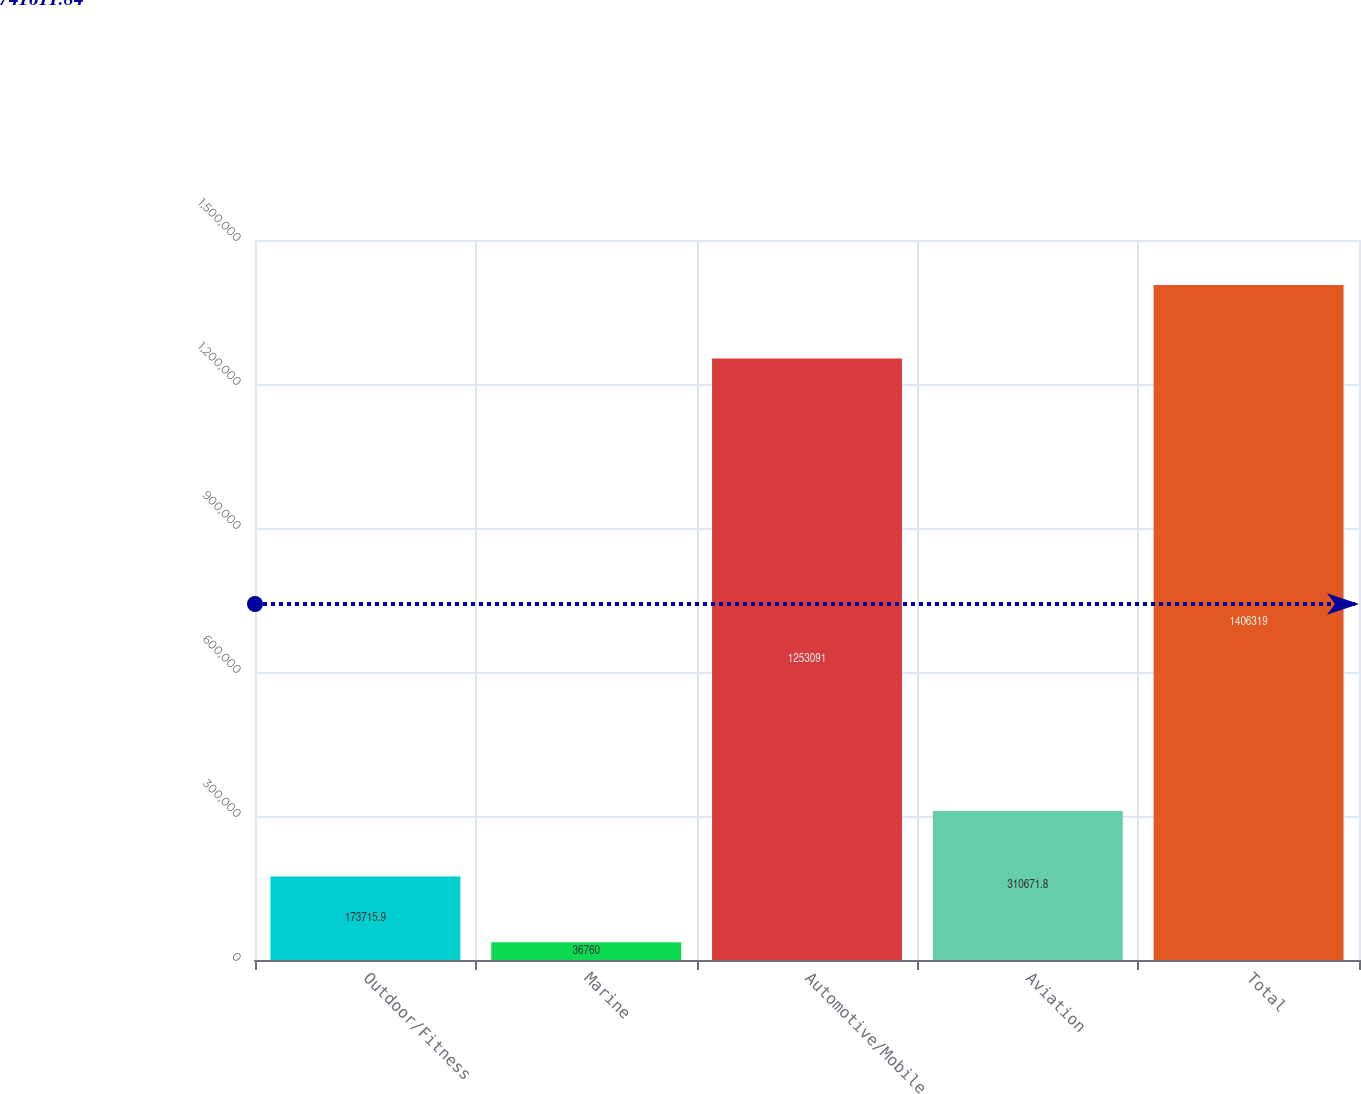<chart> <loc_0><loc_0><loc_500><loc_500><bar_chart><fcel>Outdoor/Fitness<fcel>Marine<fcel>Automotive/Mobile<fcel>Aviation<fcel>Total<nl><fcel>173716<fcel>36760<fcel>1.25309e+06<fcel>310672<fcel>1.40632e+06<nl></chart> 